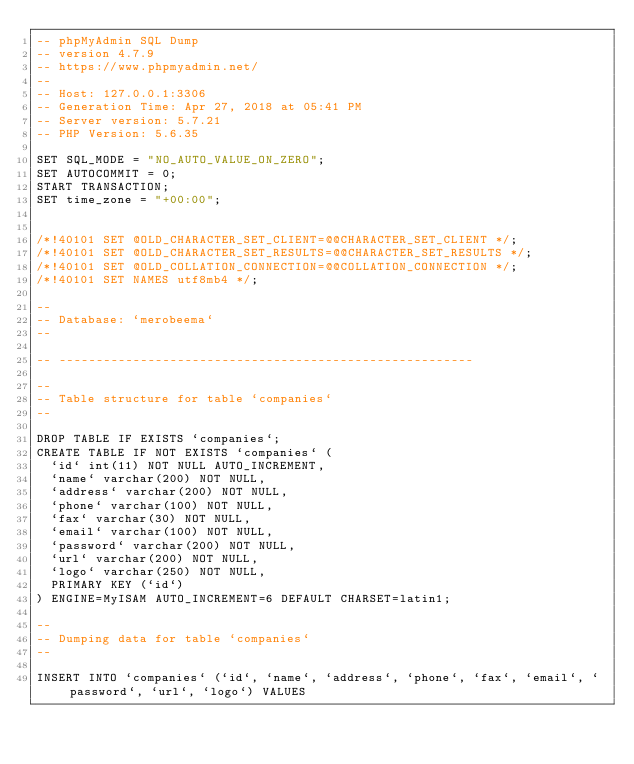<code> <loc_0><loc_0><loc_500><loc_500><_SQL_>-- phpMyAdmin SQL Dump
-- version 4.7.9
-- https://www.phpmyadmin.net/
--
-- Host: 127.0.0.1:3306
-- Generation Time: Apr 27, 2018 at 05:41 PM
-- Server version: 5.7.21
-- PHP Version: 5.6.35

SET SQL_MODE = "NO_AUTO_VALUE_ON_ZERO";
SET AUTOCOMMIT = 0;
START TRANSACTION;
SET time_zone = "+00:00";


/*!40101 SET @OLD_CHARACTER_SET_CLIENT=@@CHARACTER_SET_CLIENT */;
/*!40101 SET @OLD_CHARACTER_SET_RESULTS=@@CHARACTER_SET_RESULTS */;
/*!40101 SET @OLD_COLLATION_CONNECTION=@@COLLATION_CONNECTION */;
/*!40101 SET NAMES utf8mb4 */;

--
-- Database: `merobeema`
--

-- --------------------------------------------------------

--
-- Table structure for table `companies`
--

DROP TABLE IF EXISTS `companies`;
CREATE TABLE IF NOT EXISTS `companies` (
  `id` int(11) NOT NULL AUTO_INCREMENT,
  `name` varchar(200) NOT NULL,
  `address` varchar(200) NOT NULL,
  `phone` varchar(100) NOT NULL,
  `fax` varchar(30) NOT NULL,
  `email` varchar(100) NOT NULL,
  `password` varchar(200) NOT NULL,
  `url` varchar(200) NOT NULL,
  `logo` varchar(250) NOT NULL,
  PRIMARY KEY (`id`)
) ENGINE=MyISAM AUTO_INCREMENT=6 DEFAULT CHARSET=latin1;

--
-- Dumping data for table `companies`
--

INSERT INTO `companies` (`id`, `name`, `address`, `phone`, `fax`, `email`, `password`, `url`, `logo`) VALUES</code> 